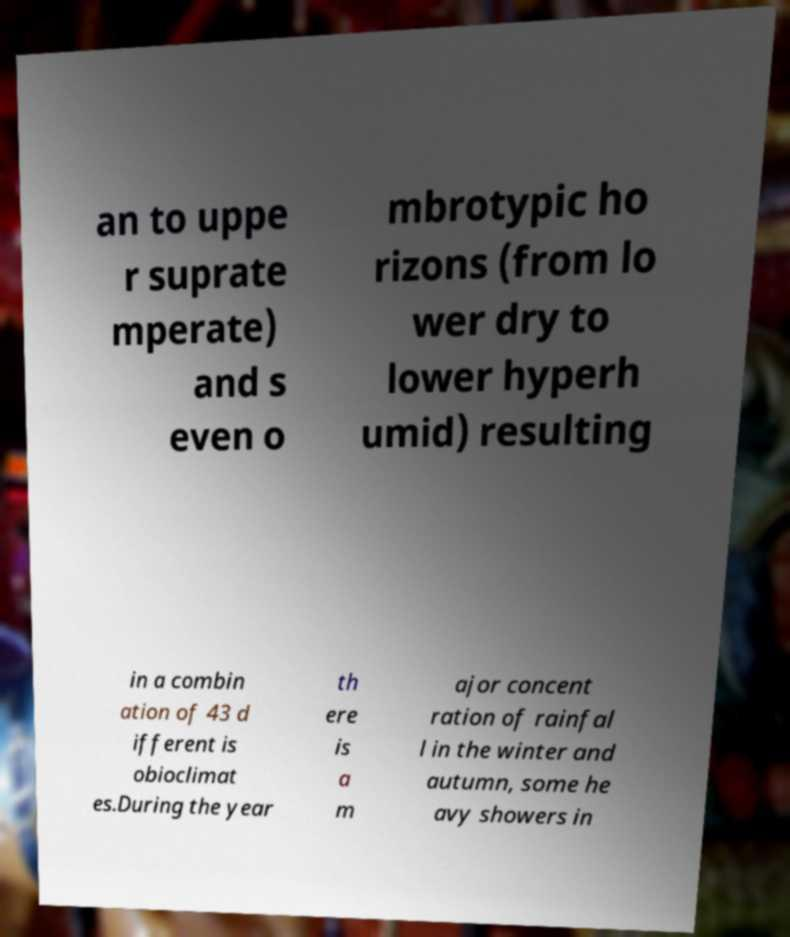Can you read and provide the text displayed in the image?This photo seems to have some interesting text. Can you extract and type it out for me? an to uppe r suprate mperate) and s even o mbrotypic ho rizons (from lo wer dry to lower hyperh umid) resulting in a combin ation of 43 d ifferent is obioclimat es.During the year th ere is a m ajor concent ration of rainfal l in the winter and autumn, some he avy showers in 